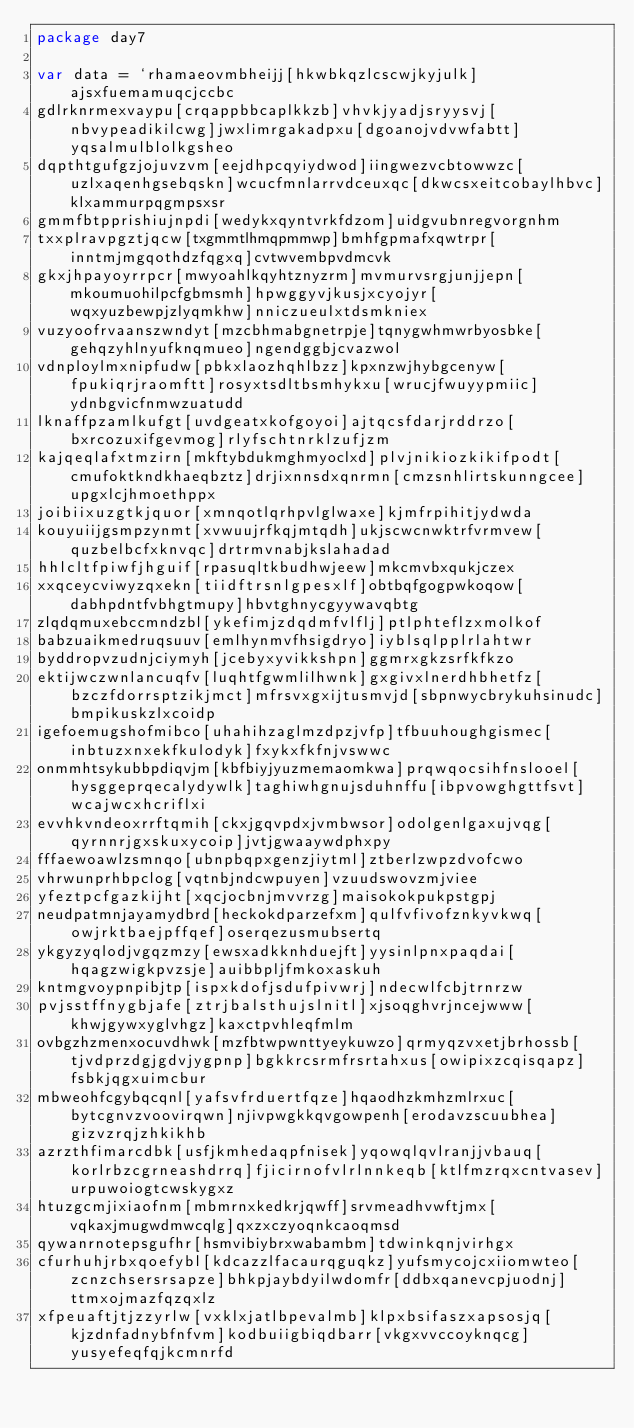<code> <loc_0><loc_0><loc_500><loc_500><_Go_>package day7

var data = `rhamaeovmbheijj[hkwbkqzlcscwjkyjulk]ajsxfuemamuqcjccbc
gdlrknrmexvaypu[crqappbbcaplkkzb]vhvkjyadjsryysvj[nbvypeadikilcwg]jwxlimrgakadpxu[dgoanojvdvwfabtt]yqsalmulblolkgsheo
dqpthtgufgzjojuvzvm[eejdhpcqyiydwod]iingwezvcbtowwzc[uzlxaqenhgsebqskn]wcucfmnlarrvdceuxqc[dkwcsxeitcobaylhbvc]klxammurpqgmpsxsr
gmmfbtpprishiujnpdi[wedykxqyntvrkfdzom]uidgvubnregvorgnhm
txxplravpgztjqcw[txgmmtlhmqpmmwp]bmhfgpmafxqwtrpr[inntmjmgqothdzfqgxq]cvtwvembpvdmcvk
gkxjhpayoyrrpcr[mwyoahlkqyhtznyzrm]mvmurvsrgjunjjepn[mkoumuohilpcfgbmsmh]hpwggyvjkusjxcyojyr[wqxyuzbewpjzlyqmkhw]nniczueulxtdsmkniex
vuzyoofrvaanszwndyt[mzcbhmabgnetrpje]tqnygwhmwrbyosbke[gehqzyhlnyufknqmueo]ngendggbjcvazwol
vdnploylmxnipfudw[pbkxlaozhqhlbzz]kpxnzwjhybgcenyw[fpukiqrjraomftt]rosyxtsdltbsmhykxu[wrucjfwuyypmiic]ydnbgvicfnmwzuatudd
lknaffpzamlkufgt[uvdgeatxkofgoyoi]ajtqcsfdarjrddrzo[bxrcozuxifgevmog]rlyfschtnrklzufjzm
kajqeqlafxtmzirn[mkftybdukmghmyoclxd]plvjnikiozkikifpodt[cmufoktkndkhaeqbztz]drjixnnsdxqnrmn[cmzsnhlirtskunngcee]upgxlcjhmoethppx
joibiixuzgtkjquor[xmnqotlqrhpvlglwaxe]kjmfrpihitjydwda
kouyuiijgsmpzynmt[xvwuujrfkqjmtqdh]ukjscwcnwktrfvrmvew[quzbelbcfxknvqc]drtrmvnabjkslahadad
hhlcltfpiwfjhguif[rpasuqltkbudhwjeew]mkcmvbxqukjczex
xxqceycviwyzqxekn[tiidftrsnlgpesxlf]obtbqfgogpwkoqow[dabhpdntfvbhgtmupy]hbvtghnycgyywavqbtg
zlqdqmuxebccmndzbl[ykefimjzdqdmfvlflj]ptlphteflzxmolkof
babzuaikmedruqsuuv[emlhynmvfhsigdryo]iyblsqlpplrlahtwr
byddropvzudnjciymyh[jcebyxyvikkshpn]ggmrxgkzsrfkfkzo
ektijwczwnlancuqfv[luqhtfgwmlilhwnk]gxgivxlnerdhbhetfz[bzczfdorrsptzikjmct]mfrsvxgxijtusmvjd[sbpnwycbrykuhsinudc]bmpikuskzlxcoidp
igefoemugshofmibco[uhahihzaglmzdpzjvfp]tfbuuhoughgismec[inbtuzxnxekfkulodyk]fxykxfkfnjvswwc
onmmhtsykubbpdiqvjm[kbfbiyjyuzmemaomkwa]prqwqocsihfnslooel[hysggeprqecalydywlk]taghiwhgnujsduhnffu[ibpvowghgttfsvt]wcajwcxhcriflxi
evvhkvndeoxrrftqmih[ckxjgqvpdxjvmbwsor]odolgenlgaxujvqg[qyrnnrjgxskuxycoip]jvtjgwaaywdphxpy
fffaewoawlzsmnqo[ubnpbqpxgenzjiytml]ztberlzwpzdvofcwo
vhrwunprhbpclog[vqtnbjndcwpuyen]vzuudswovzmjviee
yfeztpcfgazkijht[xqcjocbnjmvvrzg]maisokokpukpstgpj
neudpatmnjayamydbrd[heckokdparzefxm]qulfvfivofznkyvkwq[owjrktbaejpffqef]oserqezusmubsertq
ykgyzyqlodjvgqzmzy[ewsxadkknhduejft]yysinlpnxpaqdai[hqagzwigkpvzsje]auibbpljfmkoxaskuh
kntmgvoypnpibjtp[ispxkdofjsdufpivwrj]ndecwlfcbjtrnrzw
pvjsstffnygbjafe[ztrjbalsthujslnitl]xjsoqghvrjncejwww[khwjgywxyglvhgz]kaxctpvhleqfmlm
ovbgzhzmenxocuvdhwk[mzfbtwpwnttyeykuwzo]qrmyqzvxetjbrhossb[tjvdprzdgjgdvjygpnp]bgkkrcsrmfrsrtahxus[owipixzcqisqapz]fsbkjqgxuimcbur
mbweohfcgybqcqnl[yafsvfrduertfqze]hqaodhzkmhzmlrxuc[bytcgnvzvoovirqwn]njivpwgkkqvgowpenh[erodavzscuubhea]gizvzrqjzhkikhb
azrzthfimarcdbk[usfjkmhedaqpfnisek]yqowqlqvlranjjvbauq[korlrbzcgrneashdrrq]fjicirnofvlrlnnkeqb[ktlfmzrqxcntvasev]urpuwoiogtcwskygxz
htuzgcmjixiaofnm[mbmrnxkedkrjqwff]srvmeadhvwftjmx[vqkaxjmugwdmwcqlg]qxzxczyoqnkcaoqmsd
qywanrnotepsgufhr[hsmvibiybrxwabambm]tdwinkqnjvirhgx
cfurhuhjrbxqoefybl[kdcazzlfacaurqguqkz]yufsmycojcxiiomwteo[zcnzchsersrsapze]bhkpjaybdyilwdomfr[ddbxqanevcpjuodnj]ttmxojmazfqzqxlz
xfpeuaftjtjzzyrlw[vxklxjatlbpevalmb]klpxbsifaszxapsosjq[kjzdnfadnybfnfvm]kodbuiigbiqdbarr[vkgxvvccoyknqcg]yusyefeqfqjkcmnrfd</code> 